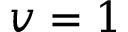Convert formula to latex. <formula><loc_0><loc_0><loc_500><loc_500>v = 1</formula> 